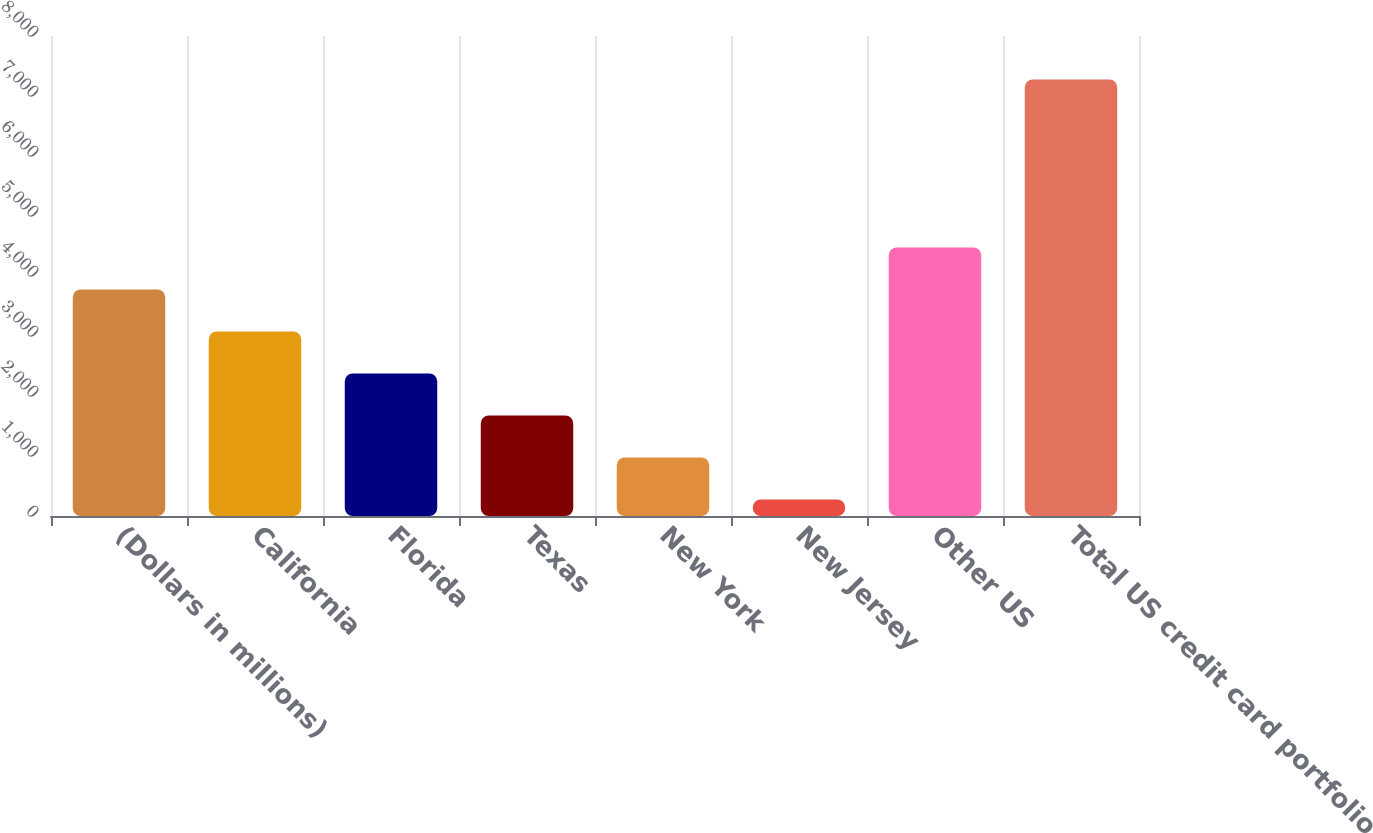Convert chart to OTSL. <chart><loc_0><loc_0><loc_500><loc_500><bar_chart><fcel>(Dollars in millions)<fcel>California<fcel>Florida<fcel>Texas<fcel>New York<fcel>New Jersey<fcel>Other US<fcel>Total US credit card portfolio<nl><fcel>3775.5<fcel>3075.4<fcel>2375.3<fcel>1675.2<fcel>975.1<fcel>275<fcel>4475.6<fcel>7276<nl></chart> 